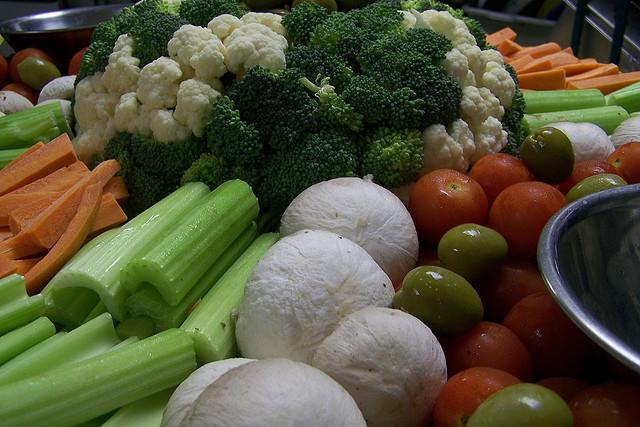What vegetables are in the basket?
Be succinct. None. Is there broccoli in this photo?
Give a very brief answer. Yes. Are the carrots peeled?
Short answer required. Yes. What is the white food?
Short answer required. Onion. How many cut up veggies are there?
Quick response, please. Lots. What is the yellow food called?
Keep it brief. Carrots. How many foods are there?
Quick response, please. 7. Are these vegetables real?
Write a very short answer. Yes. How many different vegetables are here?
Keep it brief. 7. 